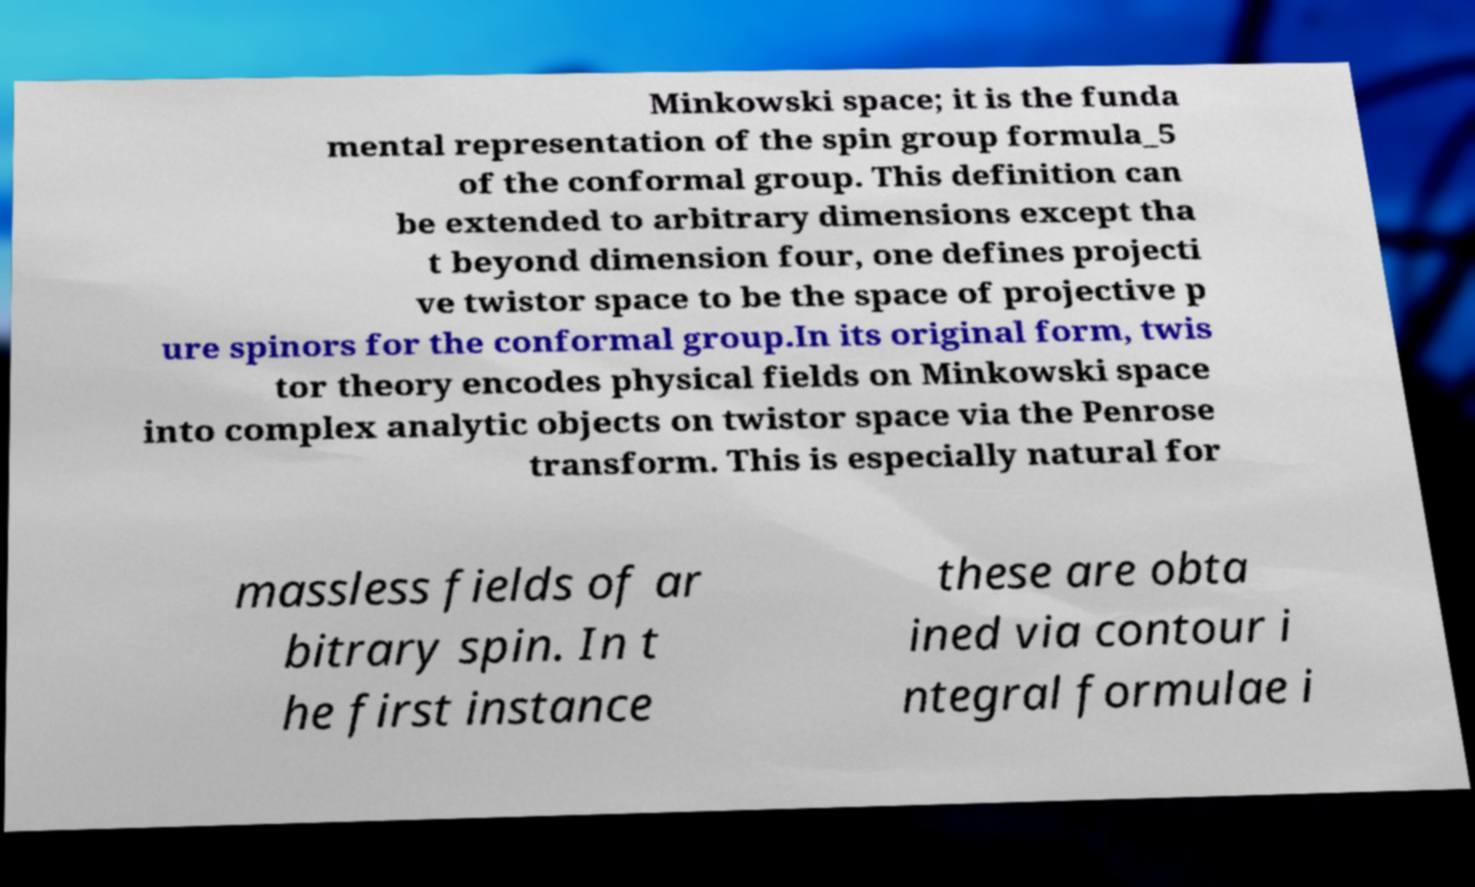Can you accurately transcribe the text from the provided image for me? Minkowski space; it is the funda mental representation of the spin group formula_5 of the conformal group. This definition can be extended to arbitrary dimensions except tha t beyond dimension four, one defines projecti ve twistor space to be the space of projective p ure spinors for the conformal group.In its original form, twis tor theory encodes physical fields on Minkowski space into complex analytic objects on twistor space via the Penrose transform. This is especially natural for massless fields of ar bitrary spin. In t he first instance these are obta ined via contour i ntegral formulae i 